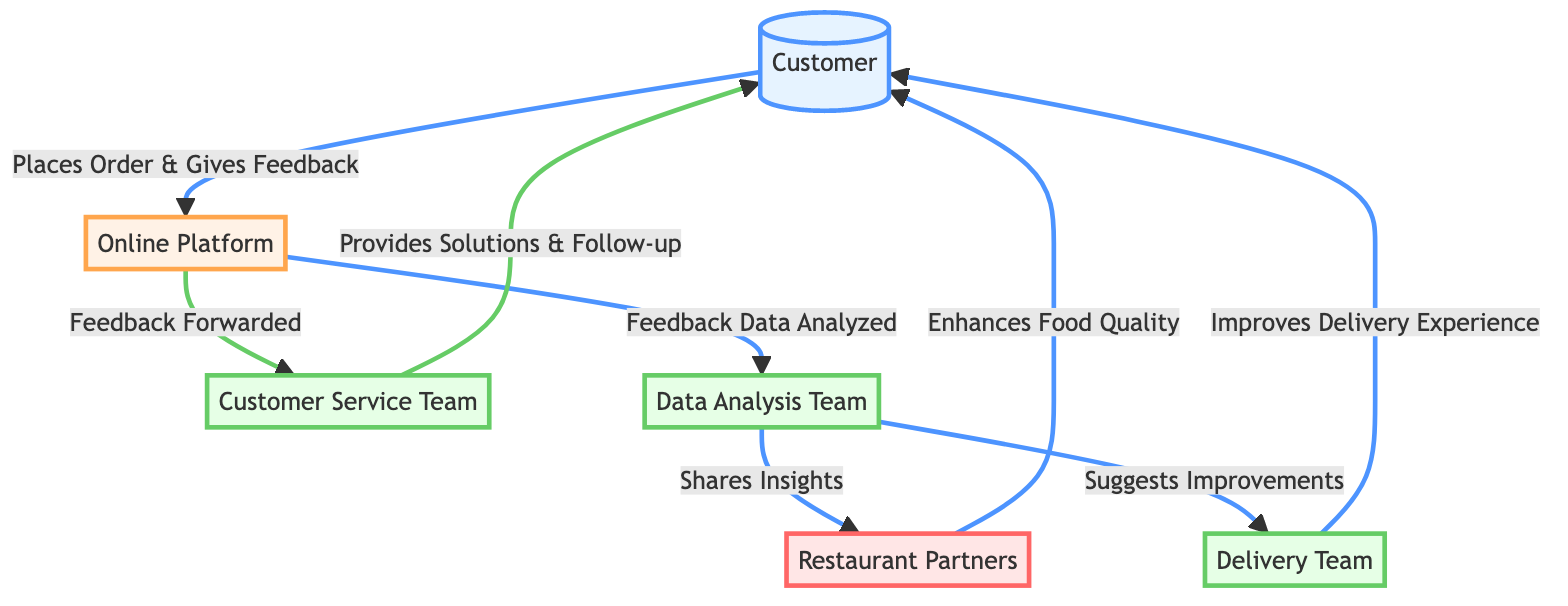What is the first node in the diagram? The diagram starts with the node labeled "Customer," which indicates the first actor in the feedback loop for online food delivery services.
Answer: Customer How many total nodes are there in the diagram? The diagram consists of six nodes, which include the Customer, Online Platform, Customer Service Team, Data Analysis Team, Restaurant Partners, and Delivery Team.
Answer: 6 What action does the "Online Platform" take after receiving feedback? The Online Platform forwards the feedback to the Customer Service Team and analyzes the feedback data, which demonstrates that it plays a central role in managing the customer feedback loop.
Answer: Feedback Forwarded & Feedback Data Analyzed Which team shares insights with the Restaurant Partners? The Data Analysis Team is responsible for sharing insights with the Restaurant Partners based on the analyzed feedback data.
Answer: Data Analysis Team What is the last action described in the diagram that improves the customer experience? The last action outlined is the Delivery Team improving the delivery experience for the customer, which helps conclude the feedback loop effectively.
Answer: Improves Delivery Experience How many paths lead from the "Data Analysis Team"? There are two paths leading from the Data Analysis Team; one shares insights with the Restaurant Partners and the other suggests improvements to the Delivery Team.
Answer: 2 Which node receives solutions and follow-ups directly? The Customer receives solutions and follow-ups directly from the Customer Service Team, illustrating the responsive nature of customer service in the feedback loop.
Answer: Customer What does the "Restaurant Partners" node enhance based on feedback? The Restaurant Partners enhance the food quality based on insights received from the Data Analysis Team, demonstrating their direct role in improving the product based on customer feedback.
Answer: Enhances Food Quality What role does the "Customer Service Team" play in the feedback loop? The Customer Service Team provides solutions and follow-up to the Customer based on feedback received from the Online Platform, making it crucial in resolving customer issues.
Answer: Provides Solutions & Follow-up 